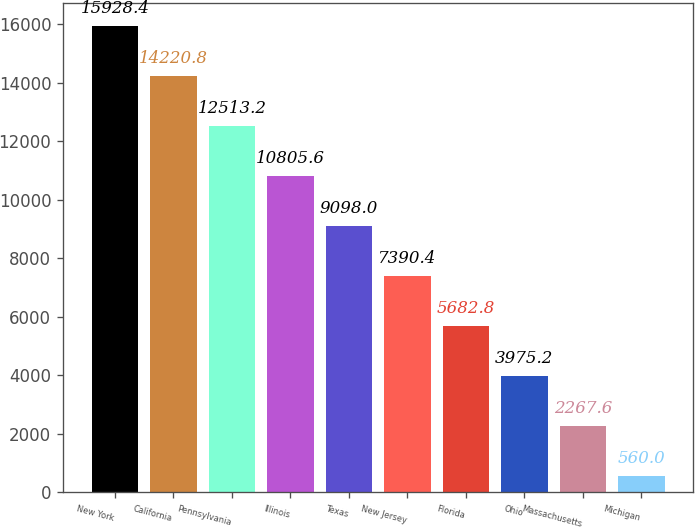Convert chart to OTSL. <chart><loc_0><loc_0><loc_500><loc_500><bar_chart><fcel>New York<fcel>California<fcel>Pennsylvania<fcel>Illinois<fcel>Texas<fcel>New Jersey<fcel>Florida<fcel>Ohio<fcel>Massachusetts<fcel>Michigan<nl><fcel>15928.4<fcel>14220.8<fcel>12513.2<fcel>10805.6<fcel>9098<fcel>7390.4<fcel>5682.8<fcel>3975.2<fcel>2267.6<fcel>560<nl></chart> 